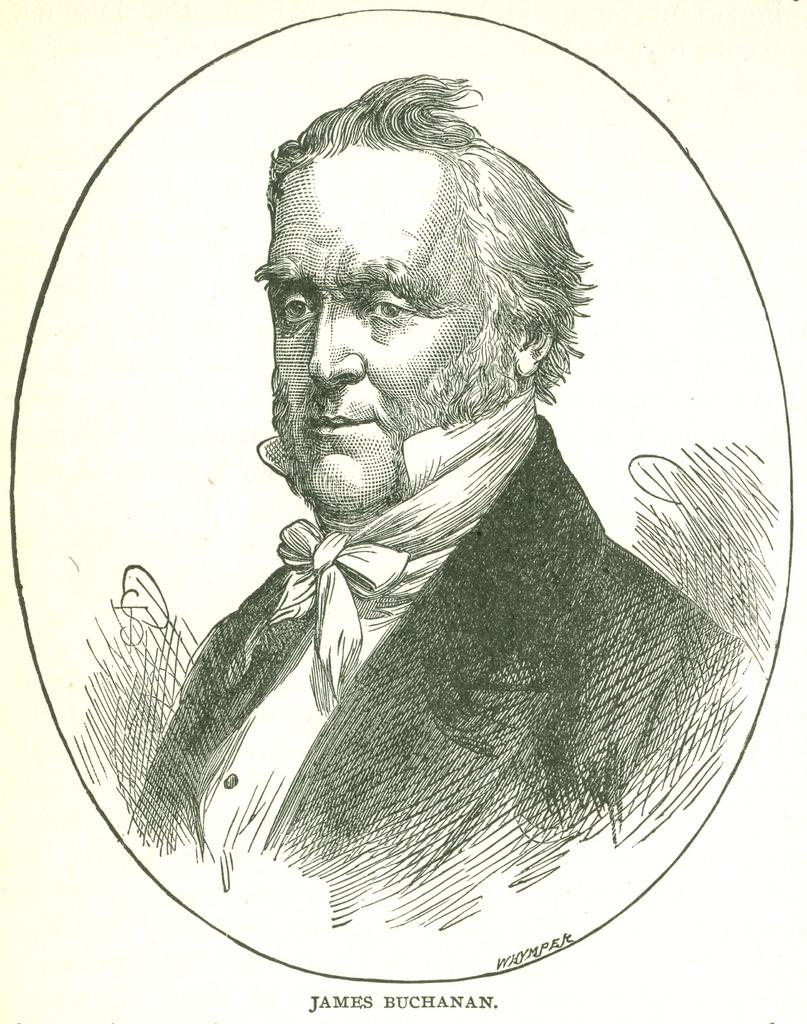What is the main subject of the image? There is a drawing in the center of the image. Can you describe the content of the drawing? The drawing contains a person. Are there any additional elements in the drawing besides the person? Yes, there is text in the drawing. How many apples are hanging from the person's ears in the drawing? There are no apples present in the drawing; it only contains a person and text. 